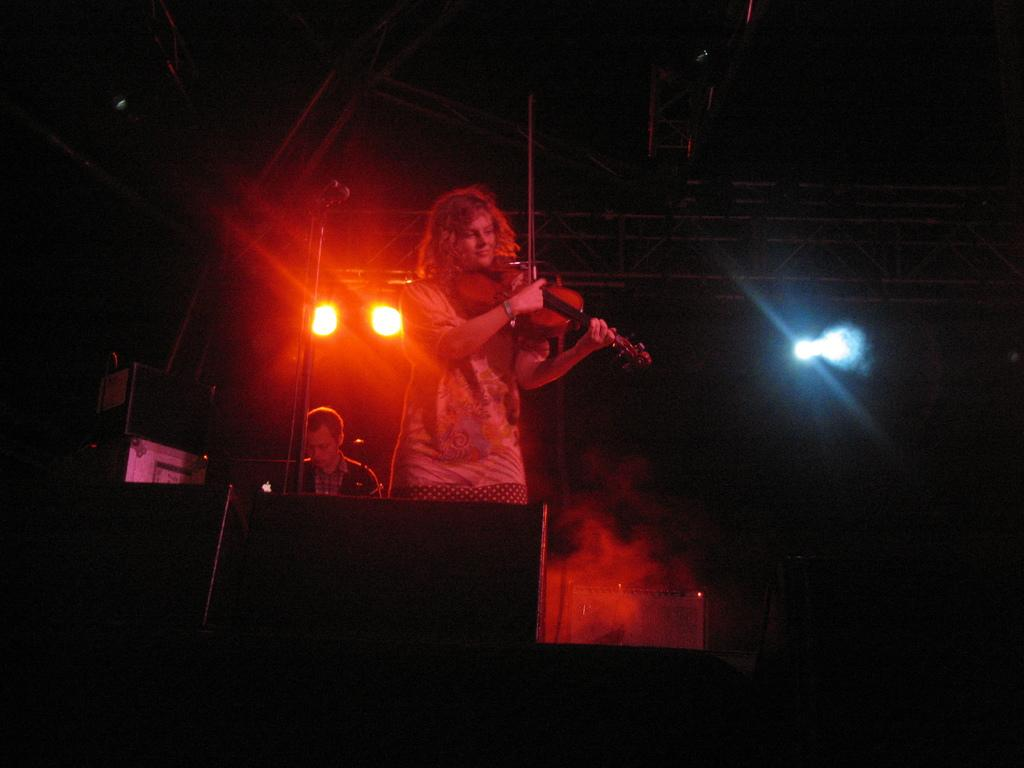What is the person in the foreground of the image doing? The person in the foreground is standing and playing the violin. Can you describe the position of the other person in the image? There is another person sitting at the back. What can be seen at the top of the image? There are lights at the top of the image. What is visible in the image that might indicate a particular atmosphere or setting? There is smoke visible in the image. How many pickles are on the violin in the image? There are no pickles present in the image, as it features a person playing the violin and another person sitting at the back. 